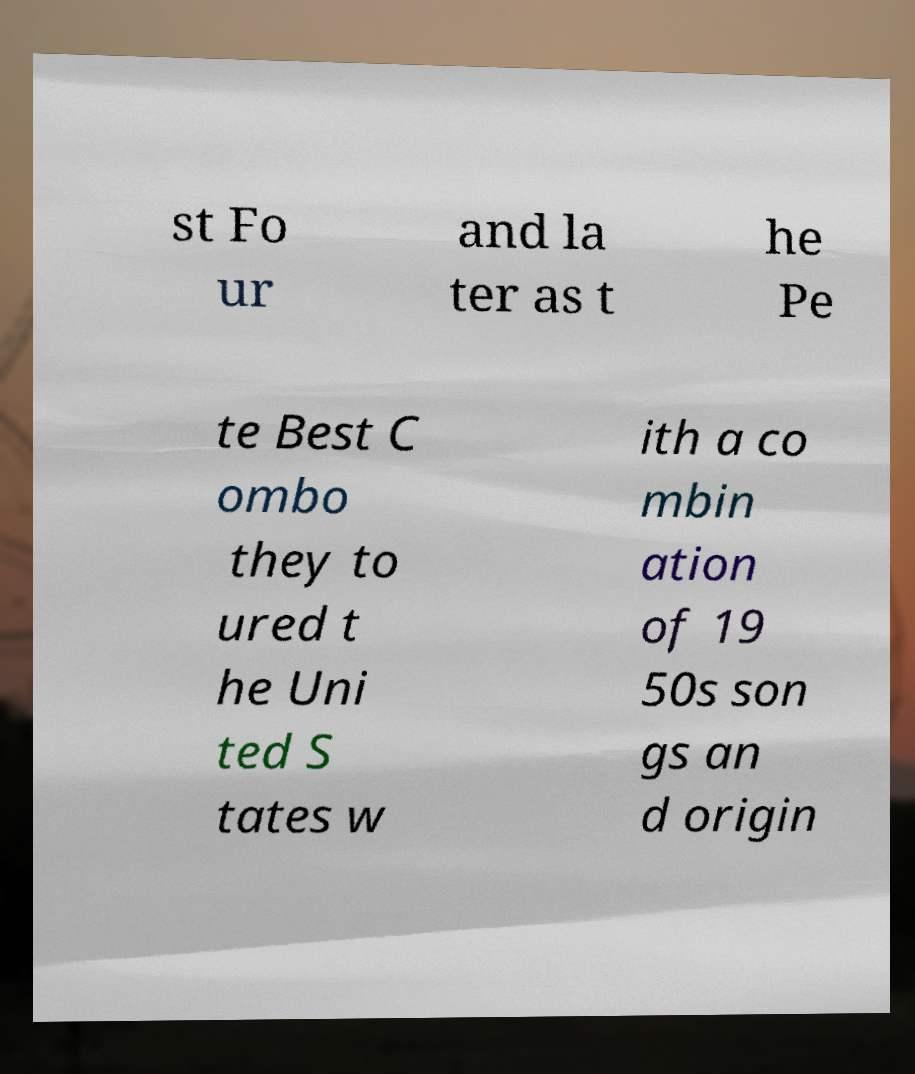Can you read and provide the text displayed in the image?This photo seems to have some interesting text. Can you extract and type it out for me? st Fo ur and la ter as t he Pe te Best C ombo they to ured t he Uni ted S tates w ith a co mbin ation of 19 50s son gs an d origin 